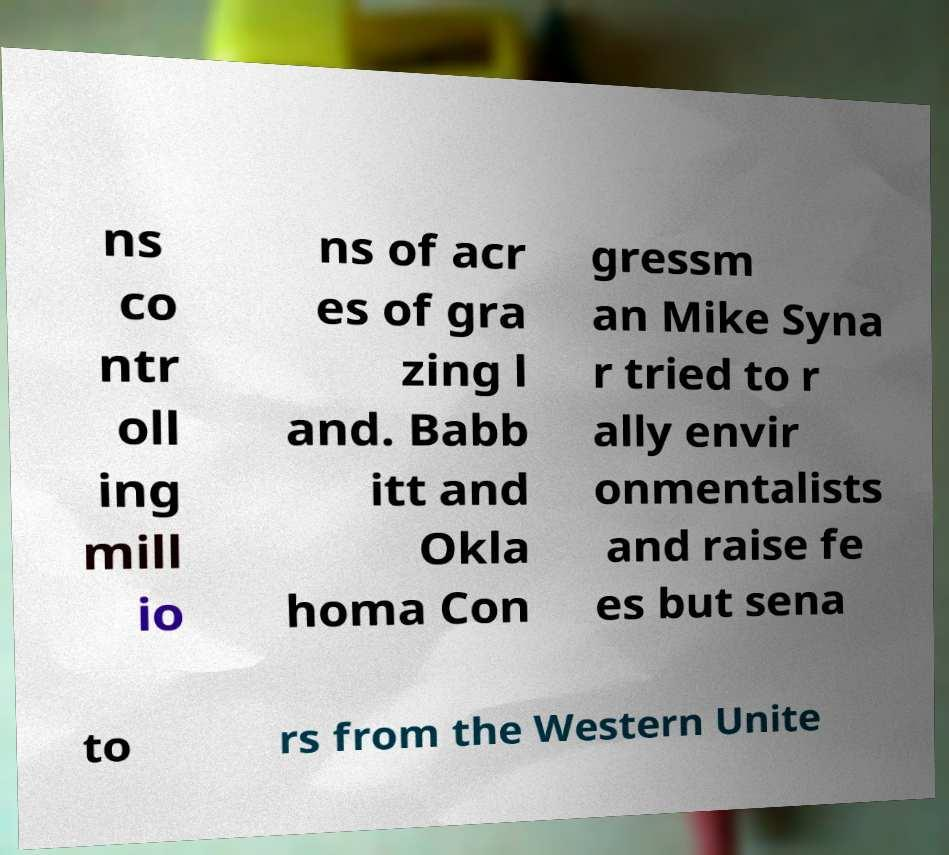What messages or text are displayed in this image? I need them in a readable, typed format. ns co ntr oll ing mill io ns of acr es of gra zing l and. Babb itt and Okla homa Con gressm an Mike Syna r tried to r ally envir onmentalists and raise fe es but sena to rs from the Western Unite 